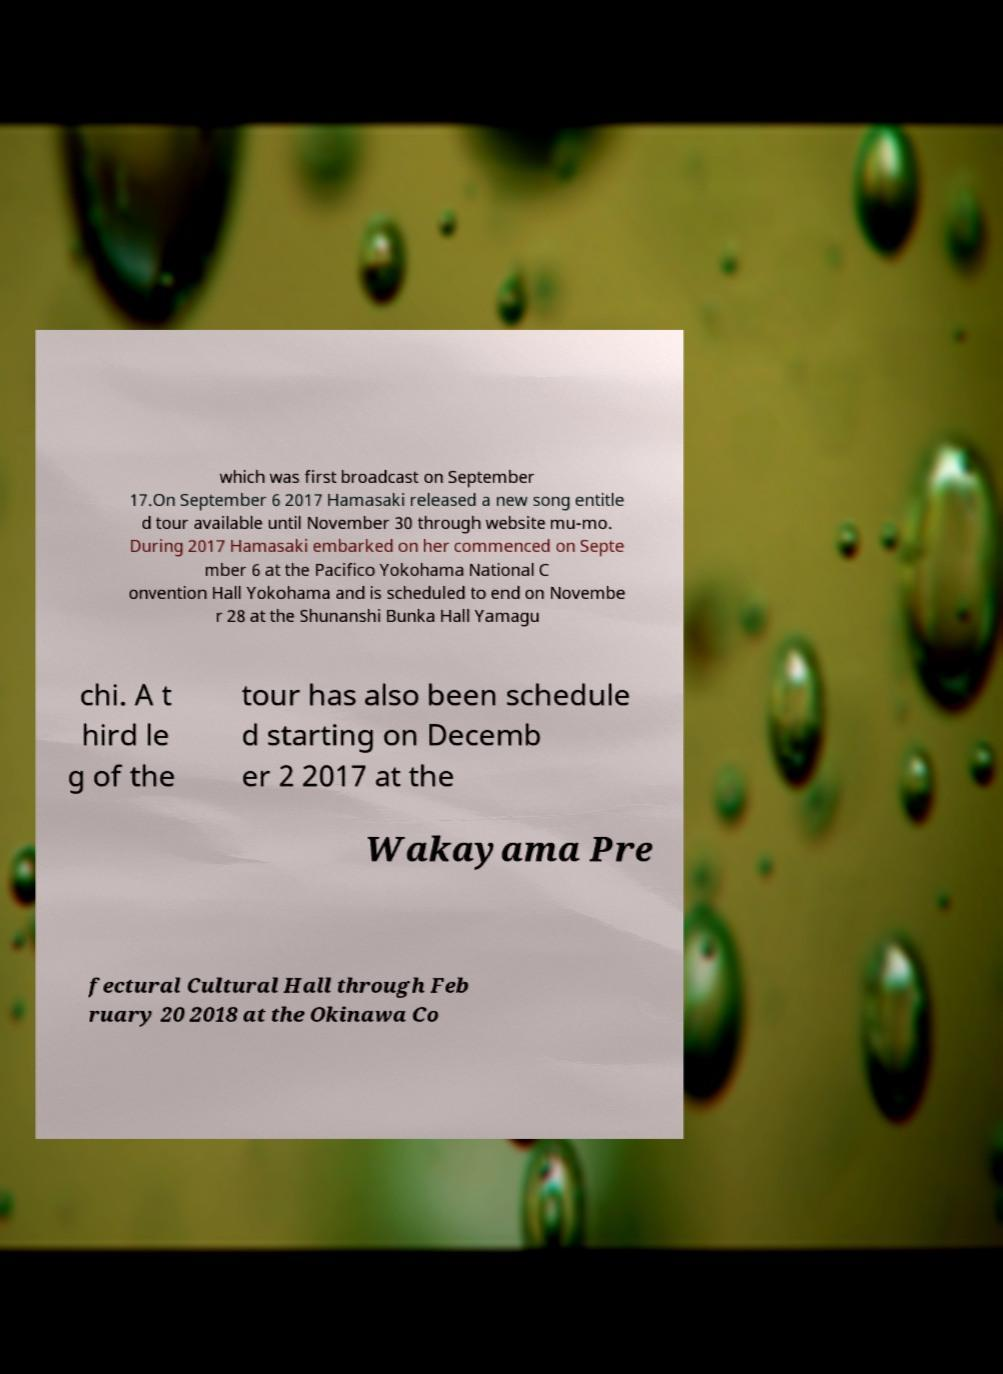I need the written content from this picture converted into text. Can you do that? which was first broadcast on September 17.On September 6 2017 Hamasaki released a new song entitle d tour available until November 30 through website mu-mo. During 2017 Hamasaki embarked on her commenced on Septe mber 6 at the Pacifico Yokohama National C onvention Hall Yokohama and is scheduled to end on Novembe r 28 at the Shunanshi Bunka Hall Yamagu chi. A t hird le g of the tour has also been schedule d starting on Decemb er 2 2017 at the Wakayama Pre fectural Cultural Hall through Feb ruary 20 2018 at the Okinawa Co 